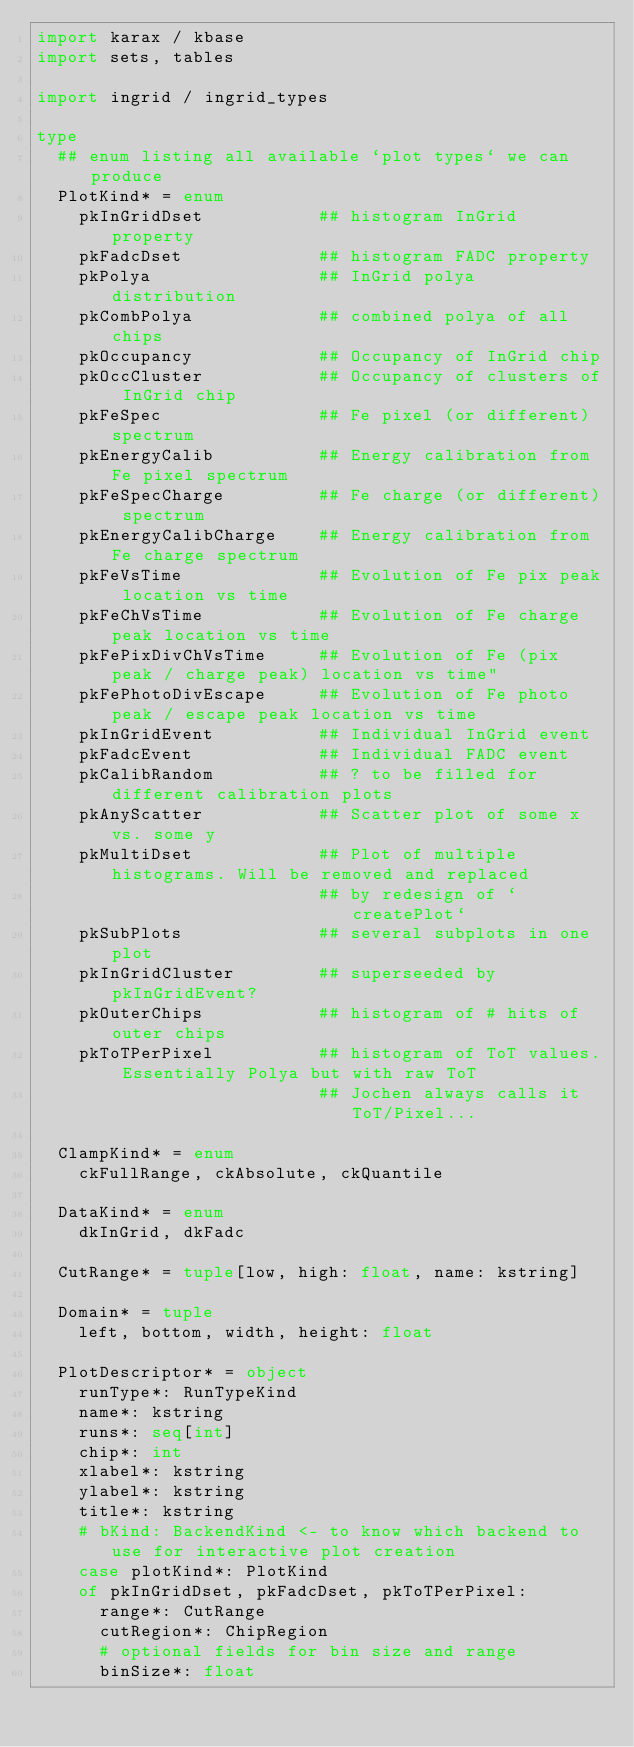Convert code to text. <code><loc_0><loc_0><loc_500><loc_500><_Nim_>import karax / kbase
import sets, tables

import ingrid / ingrid_types

type
  ## enum listing all available `plot types` we can produce
  PlotKind* = enum
    pkInGridDset           ## histogram InGrid property
    pkFadcDset             ## histogram FADC property
    pkPolya                ## InGrid polya distribution
    pkCombPolya            ## combined polya of all chips
    pkOccupancy            ## Occupancy of InGrid chip
    pkOccCluster           ## Occupancy of clusters of InGrid chip
    pkFeSpec               ## Fe pixel (or different) spectrum
    pkEnergyCalib          ## Energy calibration from Fe pixel spectrum
    pkFeSpecCharge         ## Fe charge (or different) spectrum
    pkEnergyCalibCharge    ## Energy calibration from Fe charge spectrum
    pkFeVsTime             ## Evolution of Fe pix peak location vs time
    pkFeChVsTime           ## Evolution of Fe charge peak location vs time
    pkFePixDivChVsTime     ## Evolution of Fe (pix peak / charge peak) location vs time"
    pkFePhotoDivEscape     ## Evolution of Fe photo peak / escape peak location vs time
    pkInGridEvent          ## Individual InGrid event
    pkFadcEvent            ## Individual FADC event
    pkCalibRandom          ## ? to be filled for different calibration plots
    pkAnyScatter           ## Scatter plot of some x vs. some y
    pkMultiDset            ## Plot of multiple histograms. Will be removed and replaced
                           ## by redesign of `createPlot`
    pkSubPlots             ## several subplots in one plot
    pkInGridCluster        ## superseeded by pkInGridEvent?
    pkOuterChips           ## histogram of # hits of outer chips
    pkToTPerPixel          ## histogram of ToT values. Essentially Polya but with raw ToT
                           ## Jochen always calls it ToT/Pixel...

  ClampKind* = enum
    ckFullRange, ckAbsolute, ckQuantile

  DataKind* = enum
    dkInGrid, dkFadc

  CutRange* = tuple[low, high: float, name: kstring]

  Domain* = tuple
    left, bottom, width, height: float

  PlotDescriptor* = object
    runType*: RunTypeKind
    name*: kstring
    runs*: seq[int]
    chip*: int
    xlabel*: kstring
    ylabel*: kstring
    title*: kstring
    # bKind: BackendKind <- to know which backend to use for interactive plot creation
    case plotKind*: PlotKind
    of pkInGridDset, pkFadcDset, pkToTPerPixel:
      range*: CutRange
      cutRegion*: ChipRegion
      # optional fields for bin size and range
      binSize*: float</code> 